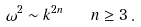Convert formula to latex. <formula><loc_0><loc_0><loc_500><loc_500>\omega ^ { 2 } \sim k ^ { 2 n } \quad n \geq 3 \, .</formula> 